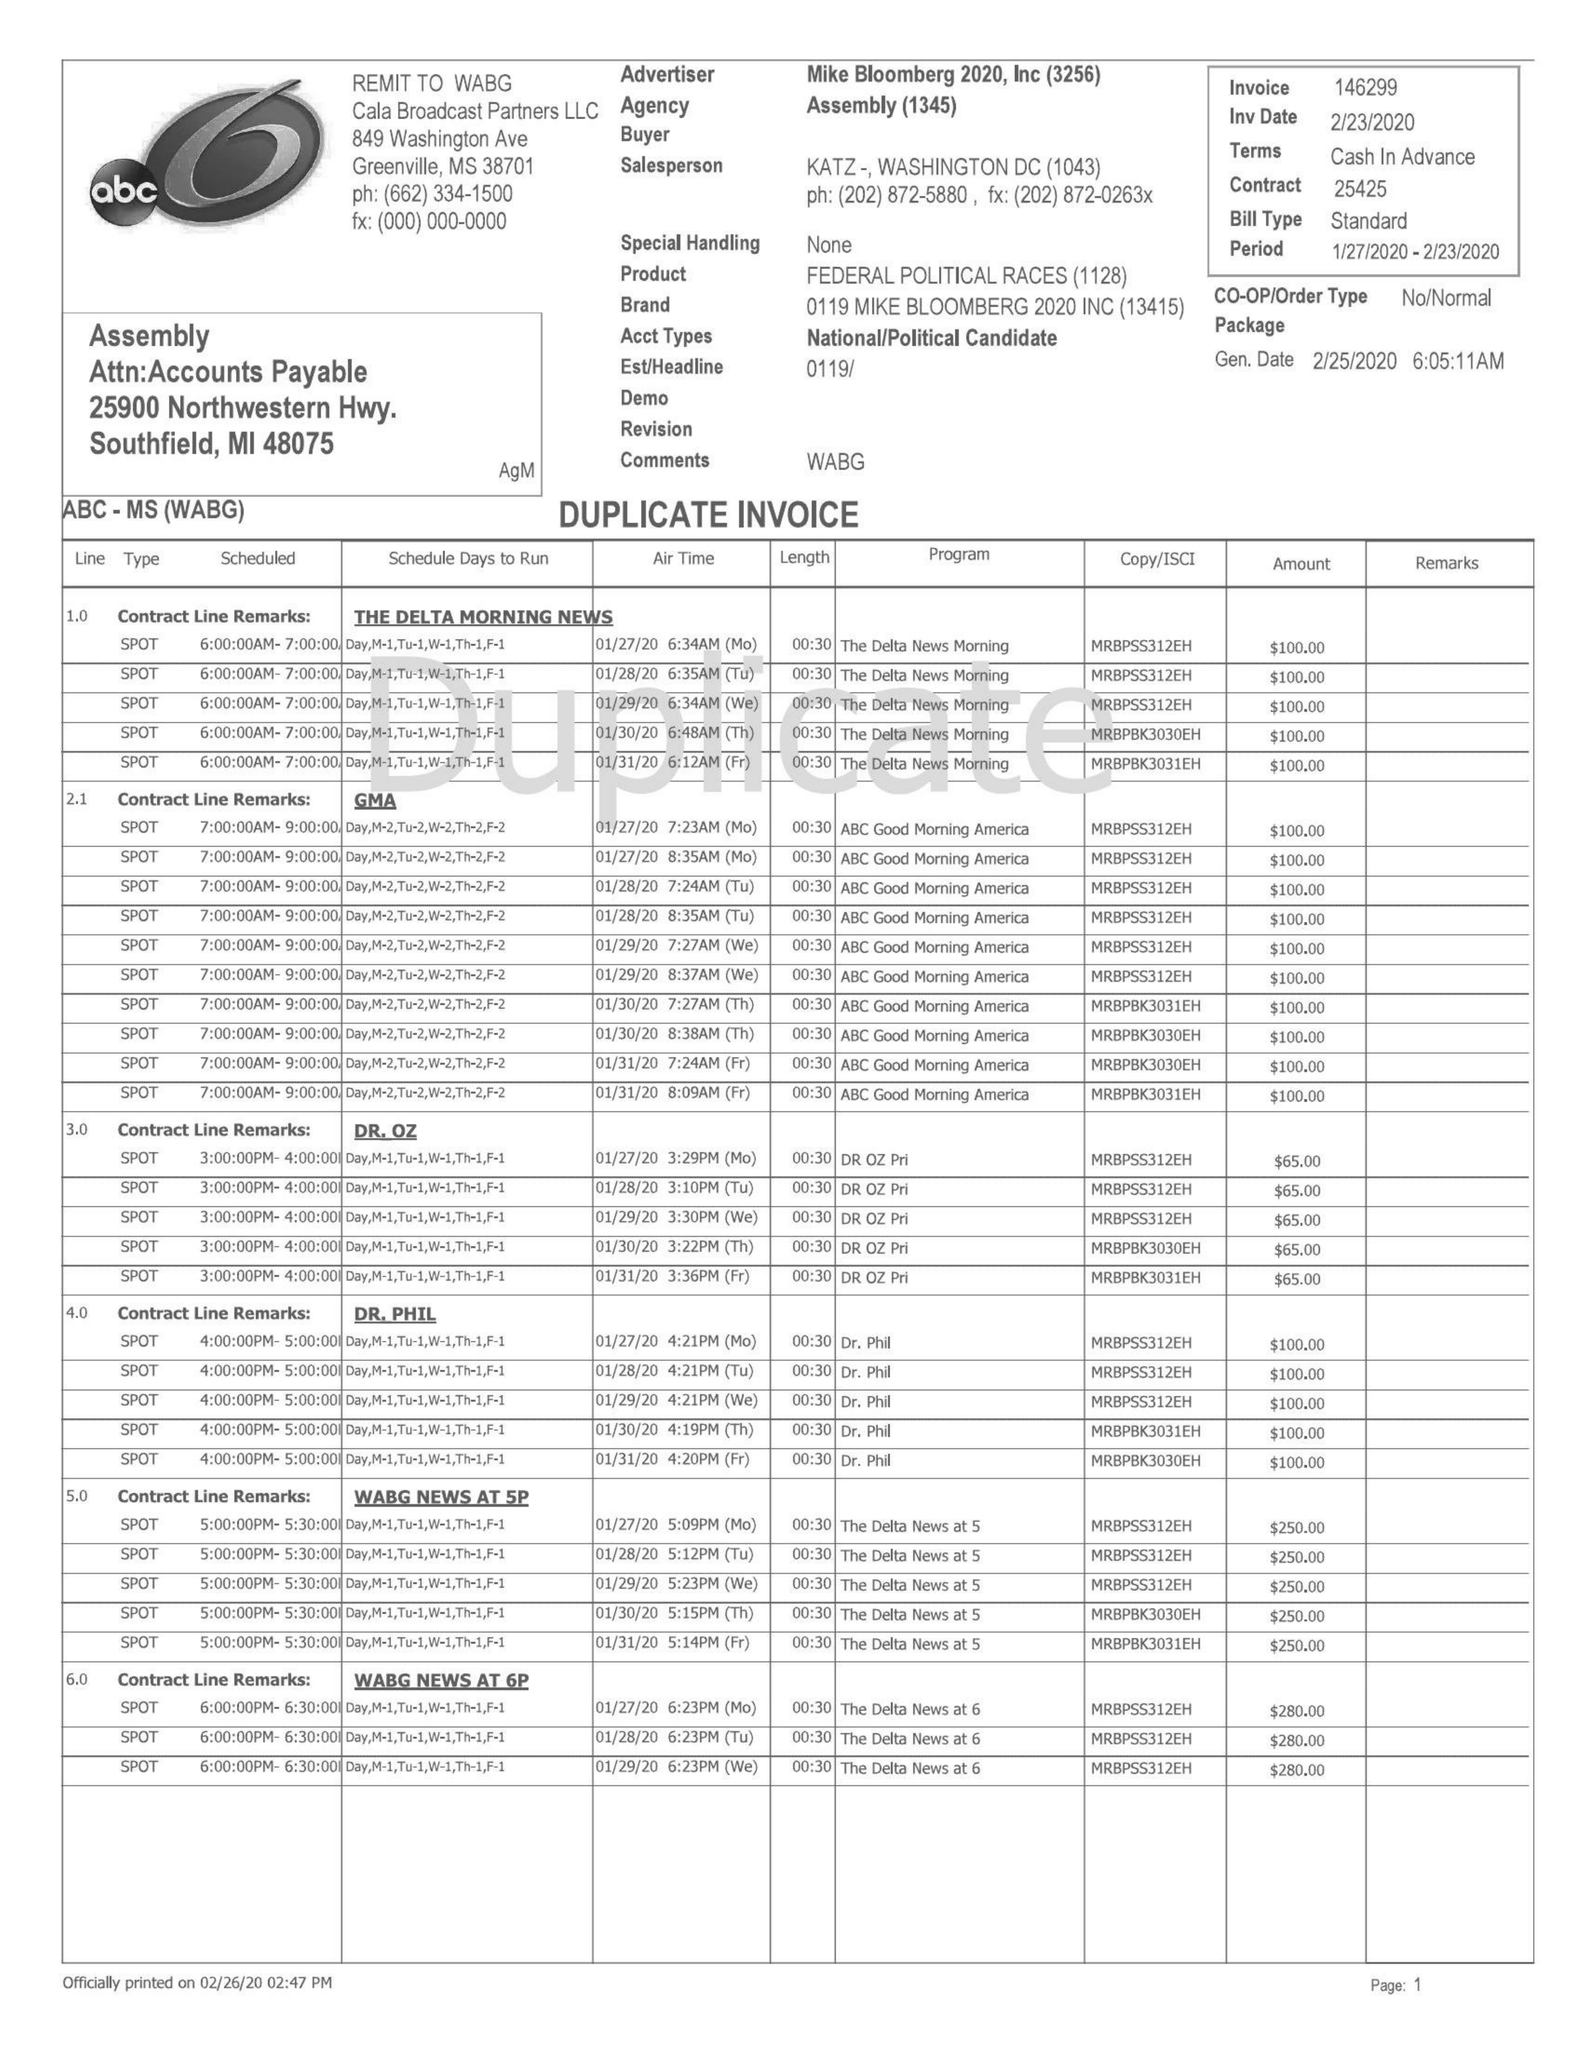What is the value for the advertiser?
Answer the question using a single word or phrase. MIKE BLOOMBERG 2020, INC 